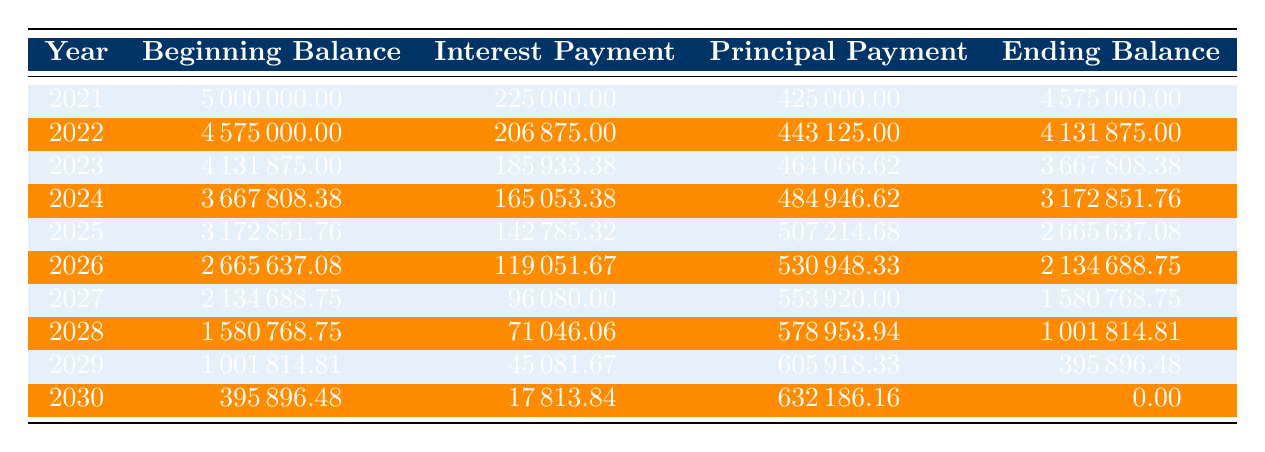What was the principal amount issued for the 2021 Bonds? The principal amount for the 2021 Bonds is listed directly in the table under the "principal_amount" key, which is 5,000,000.
Answer: 5000000 What was the total interest payment made in the year 2023? In the table, under the row for the year 2023, the interest payment is explicitly stated as 185933.38.
Answer: 185933.38 In which year was the interest payment the highest? By reviewing the interest payment values across all years in the table, the highest interest payment is 225000 in the year 2021.
Answer: 2021 What is the ending balance for the debt after the first payment in 2021? In the 2021 row of the table, the ending balance after making the first payment is given as 4575000, which is calculated by subtracting the principal payment from the beginning balance.
Answer: 4575000 What is the cumulative total of principal payments made by the end of 2025? To calculate this, we need to sum the principal payments from 2021 through 2025. The principal payments are 425000 (2021), 443125 (2022), 464066.62 (2023), 484946.62 (2024), and 507214.68 (2025). The total is 425000 + 443125 + 464066.62 + 484946.62 + 507214.68 = 2321353.92.
Answer: 2321353.92 Is the total tax revenue after debt issued lower than before debt by more than 5 percent? The total tax revenue before debt is 25000000, and after debt, it is 23500000. The reduction is 6 percent, which is indeed more than 5 percent.
Answer: Yes What was the percentage reduction in total tax revenue after the debt issuance? The percentage reduction can be calculated by taking the difference between the two revenue figures: 25000000 - 23500000 = 1500000. The percentage is then calculated as (1500000 / 25000000) * 100 = 6.
Answer: 6 Which year required the highest principal payment, and what was that amount? The highest principal payment occurs in the final year, 2030, with a payment amount of 632186.16. Analyzing the table, we see that this value is the maximum among all the years presented.
Answer: 2030, 632186.16 At the end of which year is the debt fully paid off? According to the table, the ending balance for the year 2030 is 0.00, indicating that the debt was fully paid off during that year.
Answer: 2030 